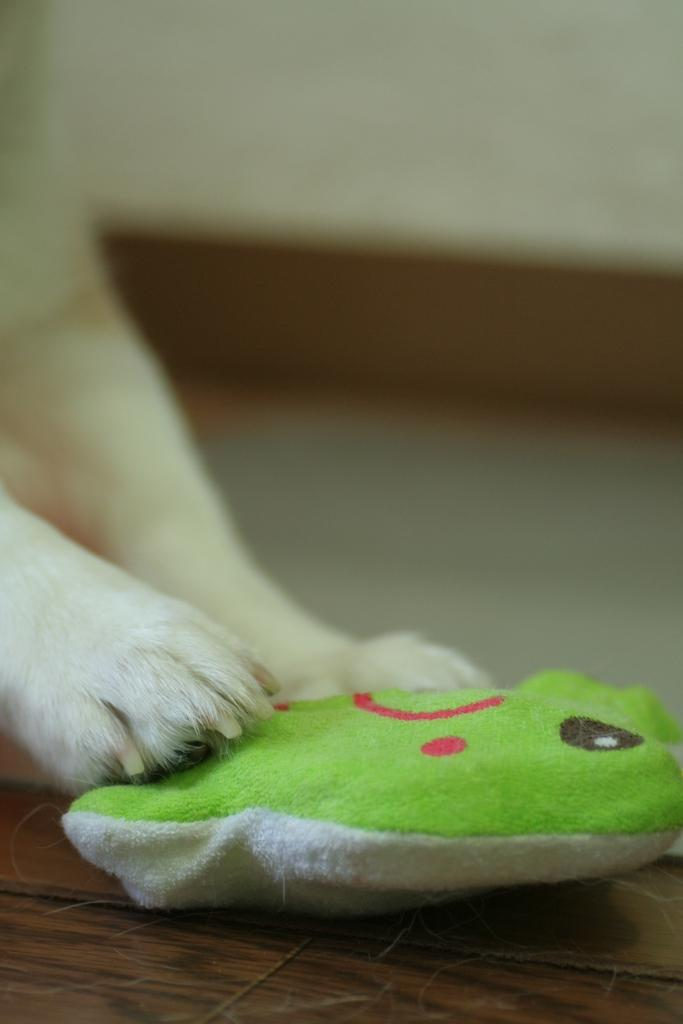What is being held by the animal legs in the image? The animal legs are holding a small green color pillow. Where is the pillow placed? The pillow is on a wooden plank. What type of soap is being used to clean the lettuce in the image? There is no soap or lettuce present in the image; it only features animal legs holding a small green color pillow on a wooden plank. 